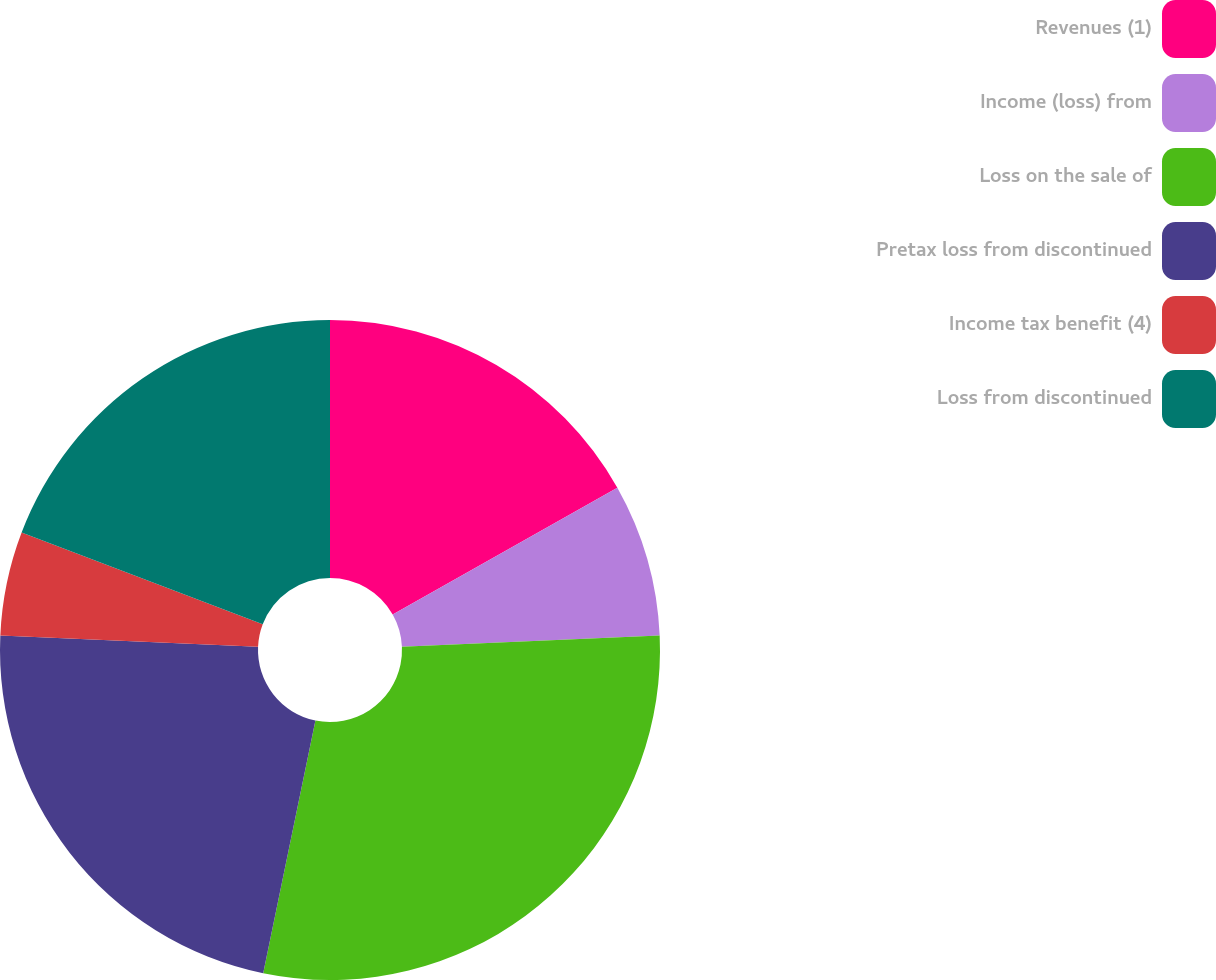<chart> <loc_0><loc_0><loc_500><loc_500><pie_chart><fcel>Revenues (1)<fcel>Income (loss) from<fcel>Loss on the sale of<fcel>Pretax loss from discontinued<fcel>Income tax benefit (4)<fcel>Loss from discontinued<nl><fcel>16.82%<fcel>7.48%<fcel>28.95%<fcel>22.46%<fcel>5.09%<fcel>19.21%<nl></chart> 